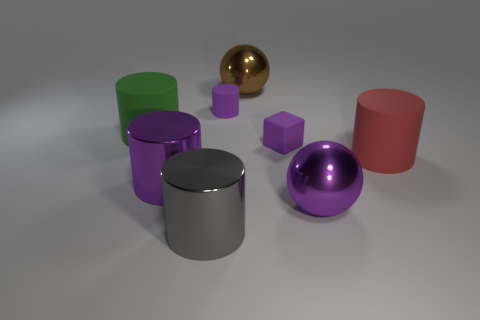What shape is the small rubber thing that is the same color as the small cylinder?
Your answer should be compact. Cube. What number of red rubber cylinders are there?
Offer a terse response. 1. What number of spheres are tiny yellow things or big purple shiny things?
Ensure brevity in your answer.  1. There is a shiny cylinder that is the same size as the gray metal thing; what color is it?
Keep it short and to the point. Purple. What number of cylinders are behind the large purple sphere and to the left of the red rubber cylinder?
Make the answer very short. 3. What material is the red object?
Your answer should be compact. Rubber. What number of things are large purple metal balls or large gray metal cylinders?
Your answer should be compact. 2. There is a ball that is in front of the large purple metal cylinder; does it have the same size as the gray object that is on the left side of the small purple cube?
Your answer should be very brief. Yes. What number of other things are the same size as the purple matte cylinder?
Your response must be concise. 1. What number of objects are big metallic things behind the red cylinder or things that are in front of the brown object?
Offer a terse response. 8. 